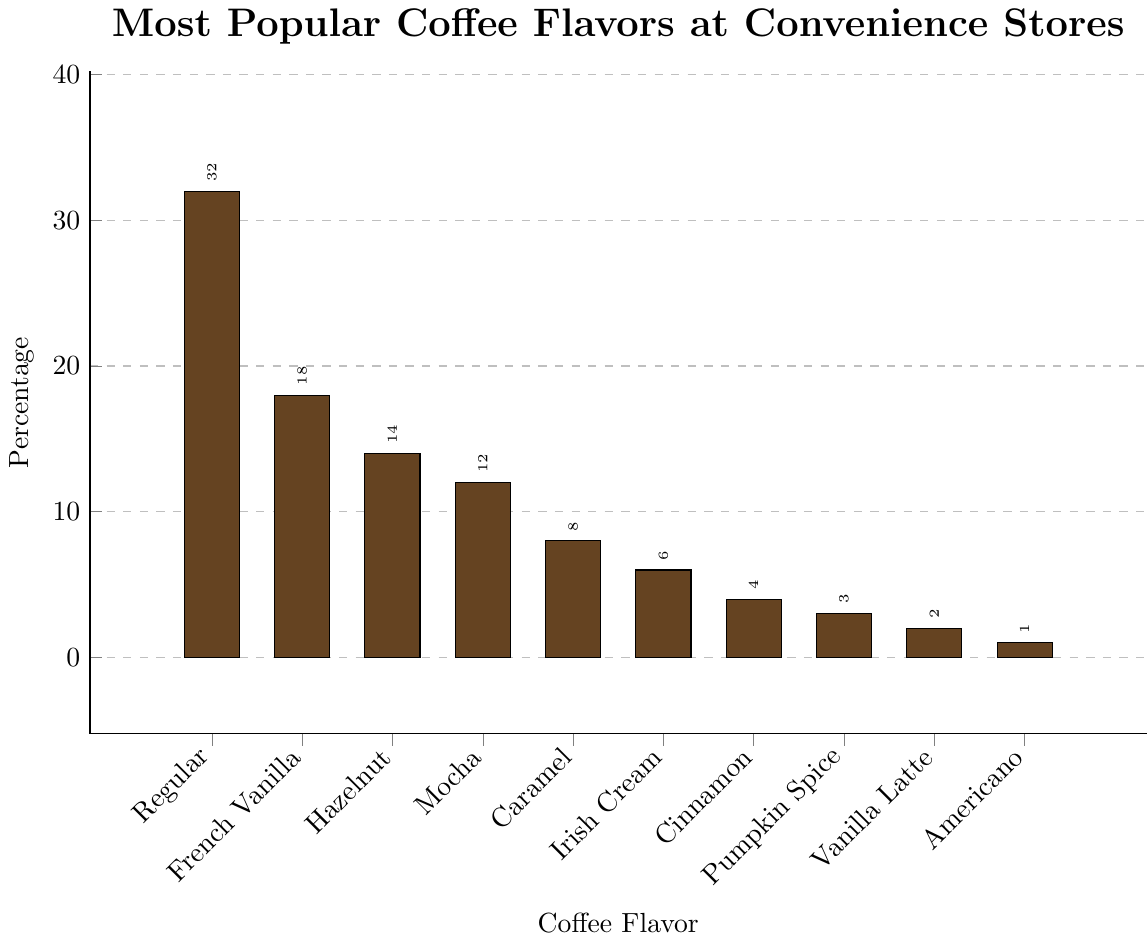Which coffee flavor is the most popular at convenience stores? The figure shows a bar chart of various coffee flavors with their respective percentages. The tallest bar represents the most popular flavor.
Answer: Regular How much more popular is Regular coffee compared to French Vanilla coffee? The percentage for Regular coffee is 32%, while for French Vanilla, it is 18%. Subtracting the French Vanilla percentage from Regular gives 32 - 18 = 14%.
Answer: 14% What is the combined popularity percentage of the top three coffee flavors? The top three coffee flavors are Regular (32%), French Vanilla (18%), and Hazelnut (14%). Adding these together gives 32 + 18 + 14 = 64%.
Answer: 64% Which coffee flavor has the smallest percentage, and what is that percentage? The bar representing Americano is the shortest, indicating it has the smallest percentage. The label shows 1%.
Answer: Americano, 1% What is the average popularity percentage of all the listed coffee flavors? Add all the percentages: 32 + 18 + 14 + 12 + 8 + 6 + 4 + 3 + 2 + 1 = 100. There are 10 flavors, so the average is 100 / 10 = 10%.
Answer: 10% How many flavors have a popularity percentage of at least 10%? By examining the figure, we can see that Regular (32%), French Vanilla (18%), Hazelnut (14%), and Mocha (12%) are all 10% or higher. This totals four flavors.
Answer: 4 Is Caramel coffee more popular than Irish Cream coffee, and by how much? Caramel has a percentage of 8%, while Irish Cream has 6%. Subtracting Irish Cream from Caramel gives 8 - 6 = 2%.
Answer: Yes, by 2% Which flavors together make up the least popular segment (totaling the lowest combined percentage)? The least popular flavors are Vanilla Latte (2%) and Americano (1%), both having percentages lower than the other flavors. Combined, their percentages are 2 + 1 = 3%.
Answer: Vanilla Latte and Americano, 3% Which flavor is the fourth most popular and its percentage? By examining the height of the bars, the fourth flavor in descending order is Mocha at 12%.
Answer: Mocha, 12% What is the difference in popularity between the most and least popular flavors? The most popular flavor is Regular at 32%, and the least popular is Americano at 1%. The difference is 32 - 1 = 31%.
Answer: 31% 